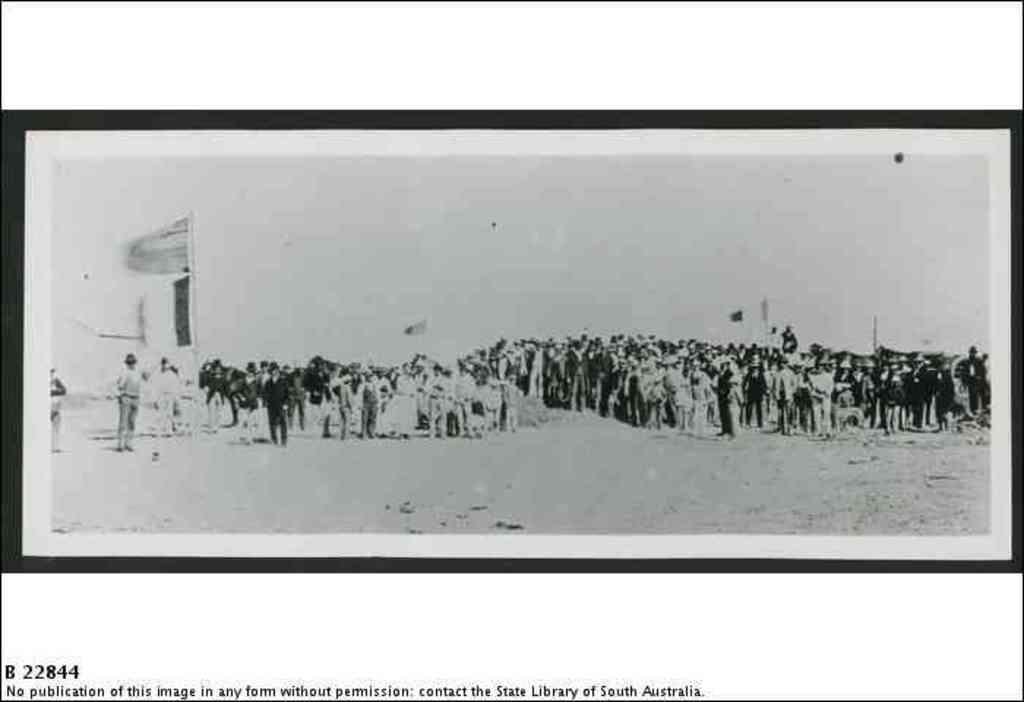<image>
Render a clear and concise summary of the photo. a copy of a photo of a crowd with the number 22844 in the corner 